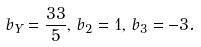<formula> <loc_0><loc_0><loc_500><loc_500>b _ { Y } = \frac { 3 3 } { 5 } , \, b _ { 2 } = 1 , \, b _ { 3 } = - 3 .</formula> 